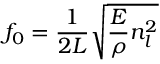Convert formula to latex. <formula><loc_0><loc_0><loc_500><loc_500>f _ { 0 } = \frac { 1 } { 2 L } \sqrt { \frac { E } { \rho } n _ { l } ^ { 2 } }</formula> 